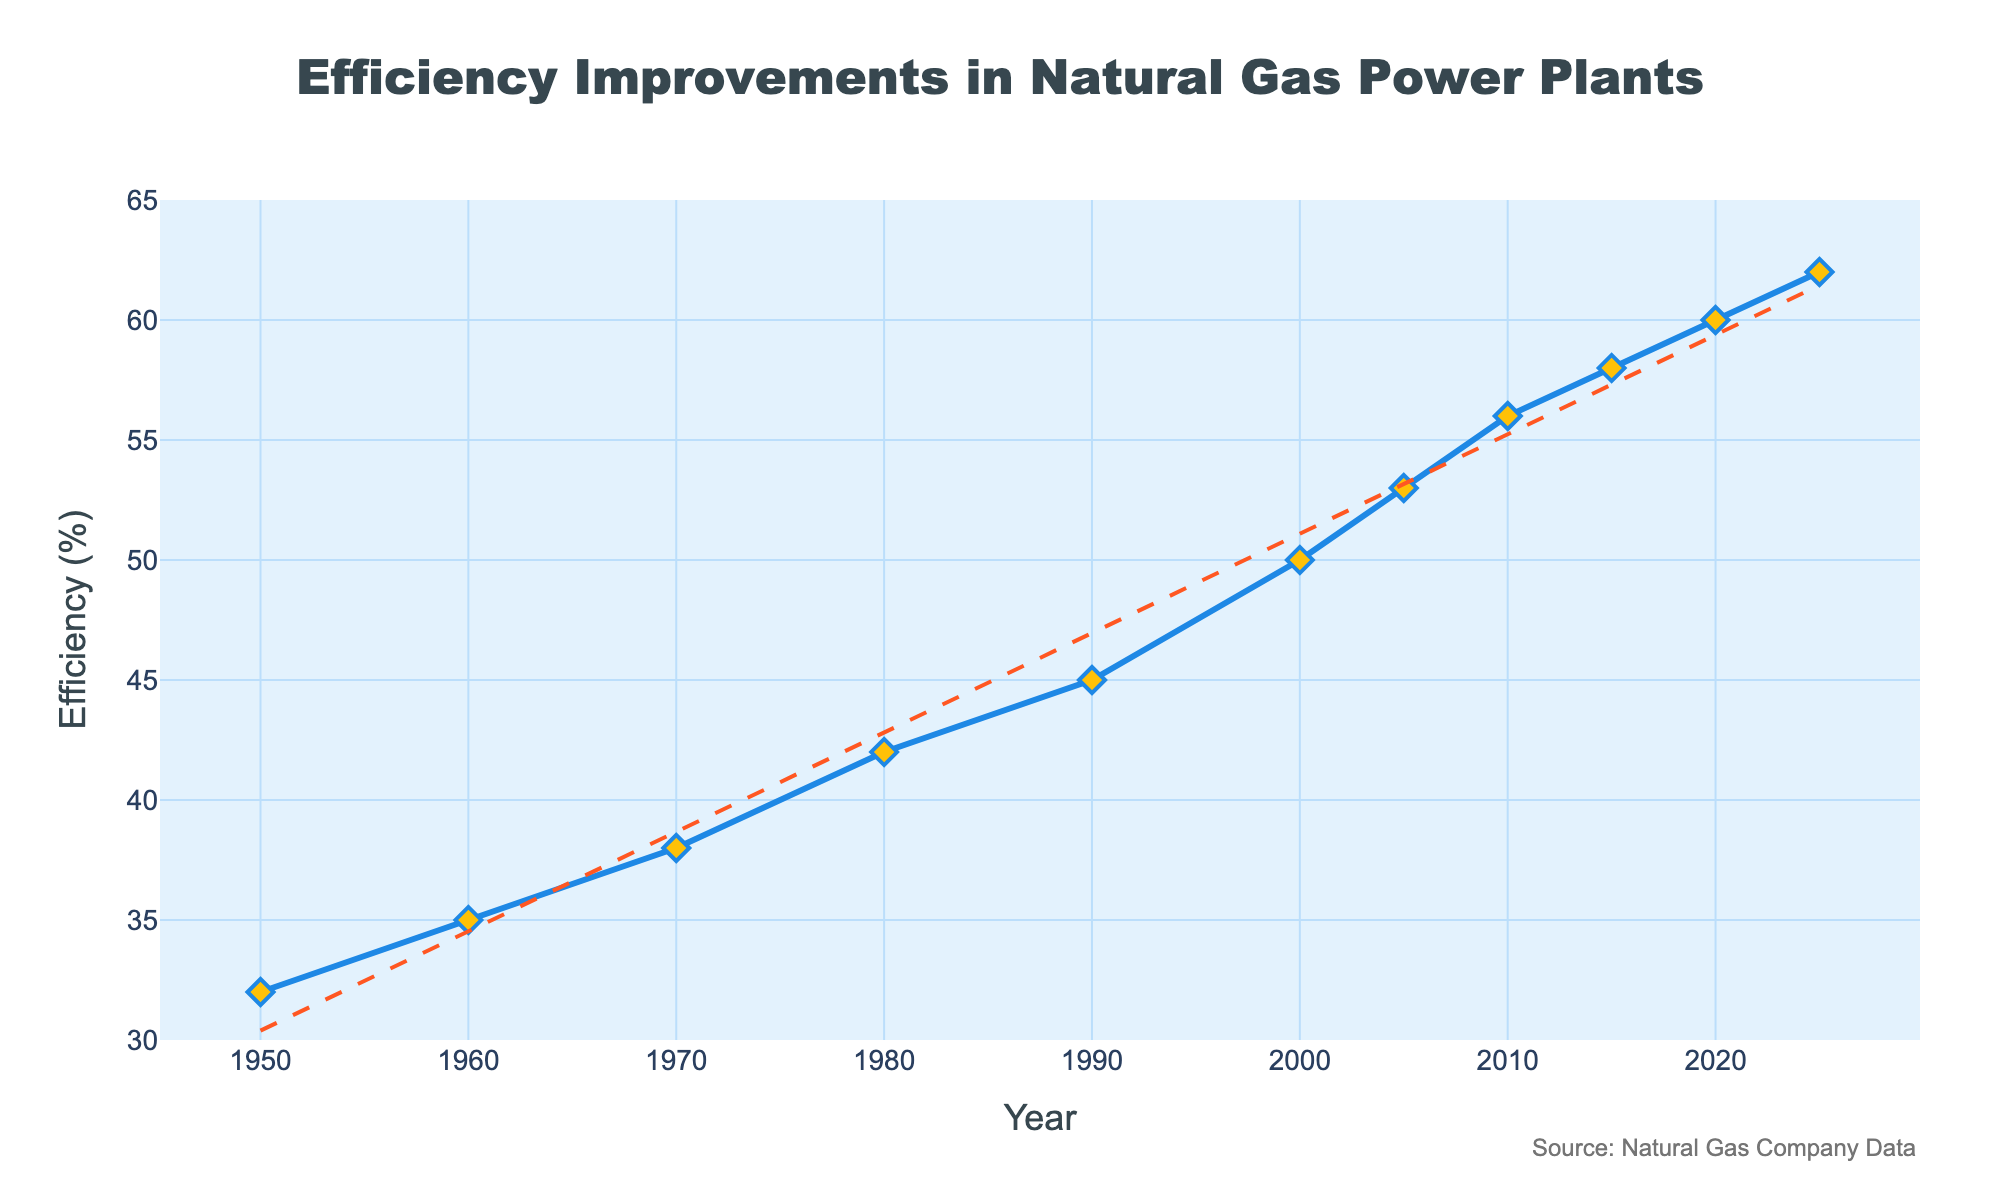What's the trend in efficiency improvements in natural gas power plants over the years? To identify the trend, observe the overall direction of the line plot from 1950 to 2025. The upward slope indicates continuous efficiency improvements over the years. Additionally, a dashed trend line supports this increasing trend.
Answer: Increasing In which year did the efficiency first exceed 50%? Locate the points on the line chart and find the year where the efficiency percentage surpasses 50%. This occurs first at the year 2000, where the efficiency hits 50%, but exceeds it in 2005.
Answer: 2005 What is the difference in efficiency between 1950 and 2025? Calculate the efficiency value in 1950 (32%) and in 2025 (62%) from the chart. Subtract the earlier value from the later value: 62% - 32% = 30%.
Answer: 30% Which period saw the most significant increase in efficiency, between 1950-1980 or 2000-2025? Calculate the efficiency increase for each period: (1980: 42% - 1950: 32%) = 10%, and (2025: 62% - 2000: 50%) = 12%. Compare the two results to determine that the increase from 2000 to 2025 is greater.
Answer: 2000-2025 What is the average efficiency from 2000 to 2025? Calculate the average efficiency by summing the efficiency values for each year data point from 2000 to 2025 (50%, 53%, 56%, 58%, 60%, 62%) and dividing by the number of data points (6). The calculation is (50 + 53 + 56 + 58 + 60 + 62) / 6 = 339 / 6 = 56.5%.
Answer: 56.5% In which decade did natural gas power plants see the greatest absolute increase in efficiency? Examine the efficiency values at the start and end of each decade from the chart. Calculate the absolute increases and find the decade with the highest value. For instance, 1980 to 1990 shows an increase from 42% to 45%, which is 3%. The greatest increase of 6% occurs between 2000 to 2010 (50% to 56%).
Answer: 2000-2010 How does the efficiency level in 2025 compare to 1990? Note the efficiency values for the years 1990 and 2025 from the chart, which are 45% and 62% respectively. Comparing them shows an increase by 17 percentage points by 2025.
Answer: Higher by 17% How did the efficiency of natural gas power plants change between 2010 and 2015? Assess the efficiency values for 2010 and 2015, which are 56% and 58% respectively. The change is an increase of 2 percentage points.
Answer: Increased by 2% How many years did it take for the efficiency to increase from 42% to 60%? Identify the year with 42% efficiency (1980) and the year with 60% efficiency (2020). Subtract the earlier year from the later year: 2020 - 1980 = 40 years.
Answer: 40 years What is the efficiency increase rate per decade from 1950 to 2025? Calculate the efficiency change over the entire period: 62% - 32% = 30%. Determine the number of decades, which is (2025 - 1950) / 10 = 7.5 decades. Divide the total increase by the number of decades: 30% / 7.5 = 4% per decade.
Answer: 4% per decade 